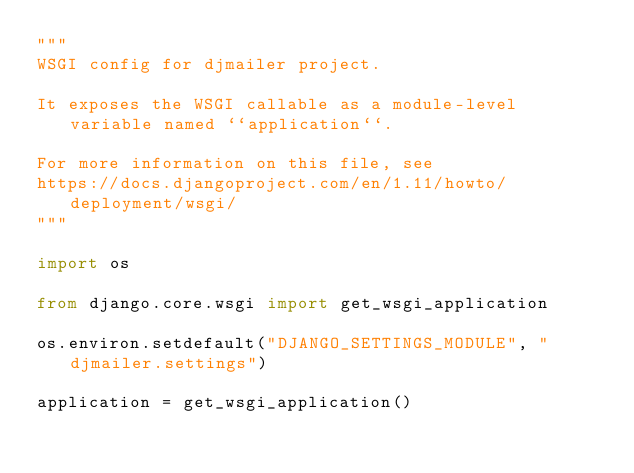<code> <loc_0><loc_0><loc_500><loc_500><_Python_>"""
WSGI config for djmailer project.

It exposes the WSGI callable as a module-level variable named ``application``.

For more information on this file, see
https://docs.djangoproject.com/en/1.11/howto/deployment/wsgi/
"""

import os

from django.core.wsgi import get_wsgi_application

os.environ.setdefault("DJANGO_SETTINGS_MODULE", "djmailer.settings")

application = get_wsgi_application()
</code> 